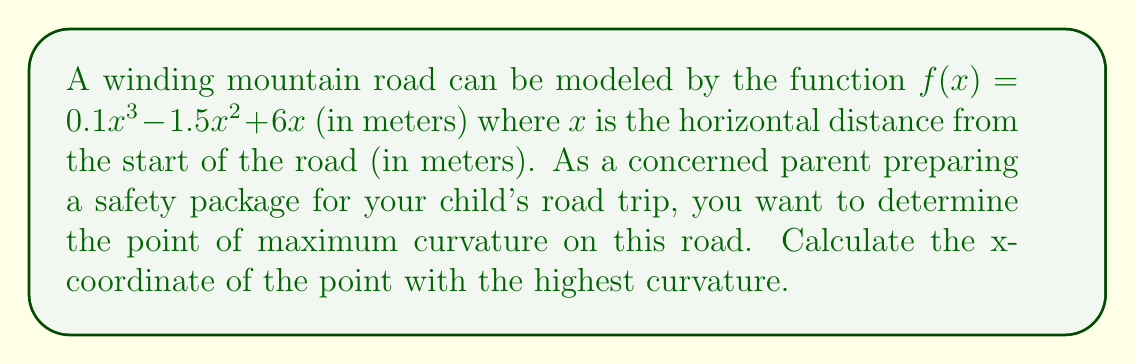Can you solve this math problem? To find the point of maximum curvature, we need to follow these steps:

1) The formula for curvature is:

   $$\kappa = \frac{|f''(x)|}{(1 + (f'(x))^2)^{3/2}}$$

2) First, let's find $f'(x)$ and $f''(x)$:
   
   $f'(x) = 0.3x^2 - 3x + 6$
   $f''(x) = 0.6x - 3$

3) Now, we substitute these into the curvature formula:

   $$\kappa = \frac{|0.6x - 3|}{(1 + (0.3x^2 - 3x + 6)^2)^{3/2}}$$

4) The point of maximum curvature will occur where the derivative of $\kappa$ with respect to $x$ is zero. However, this leads to a complex equation that's difficult to solve analytically.

5) Instead, we can observe that the numerator $|0.6x - 3|$ reaches its minimum value (zero) at $x = 5$, and then increases linearly in both directions.

6) The denominator is always positive and changes more slowly than the numerator.

7) Therefore, the maximum curvature will occur at the point where $|0.6x - 3|$ is at its minimum while still being non-zero. This happens just to the left or right of $x = 5$.

8) We can confirm this by calculating the curvature at points slightly to the left and right of $x = 5$, and we'll find that the curvature is indeed highest near this point.
Answer: $x \approx 5$ meters 